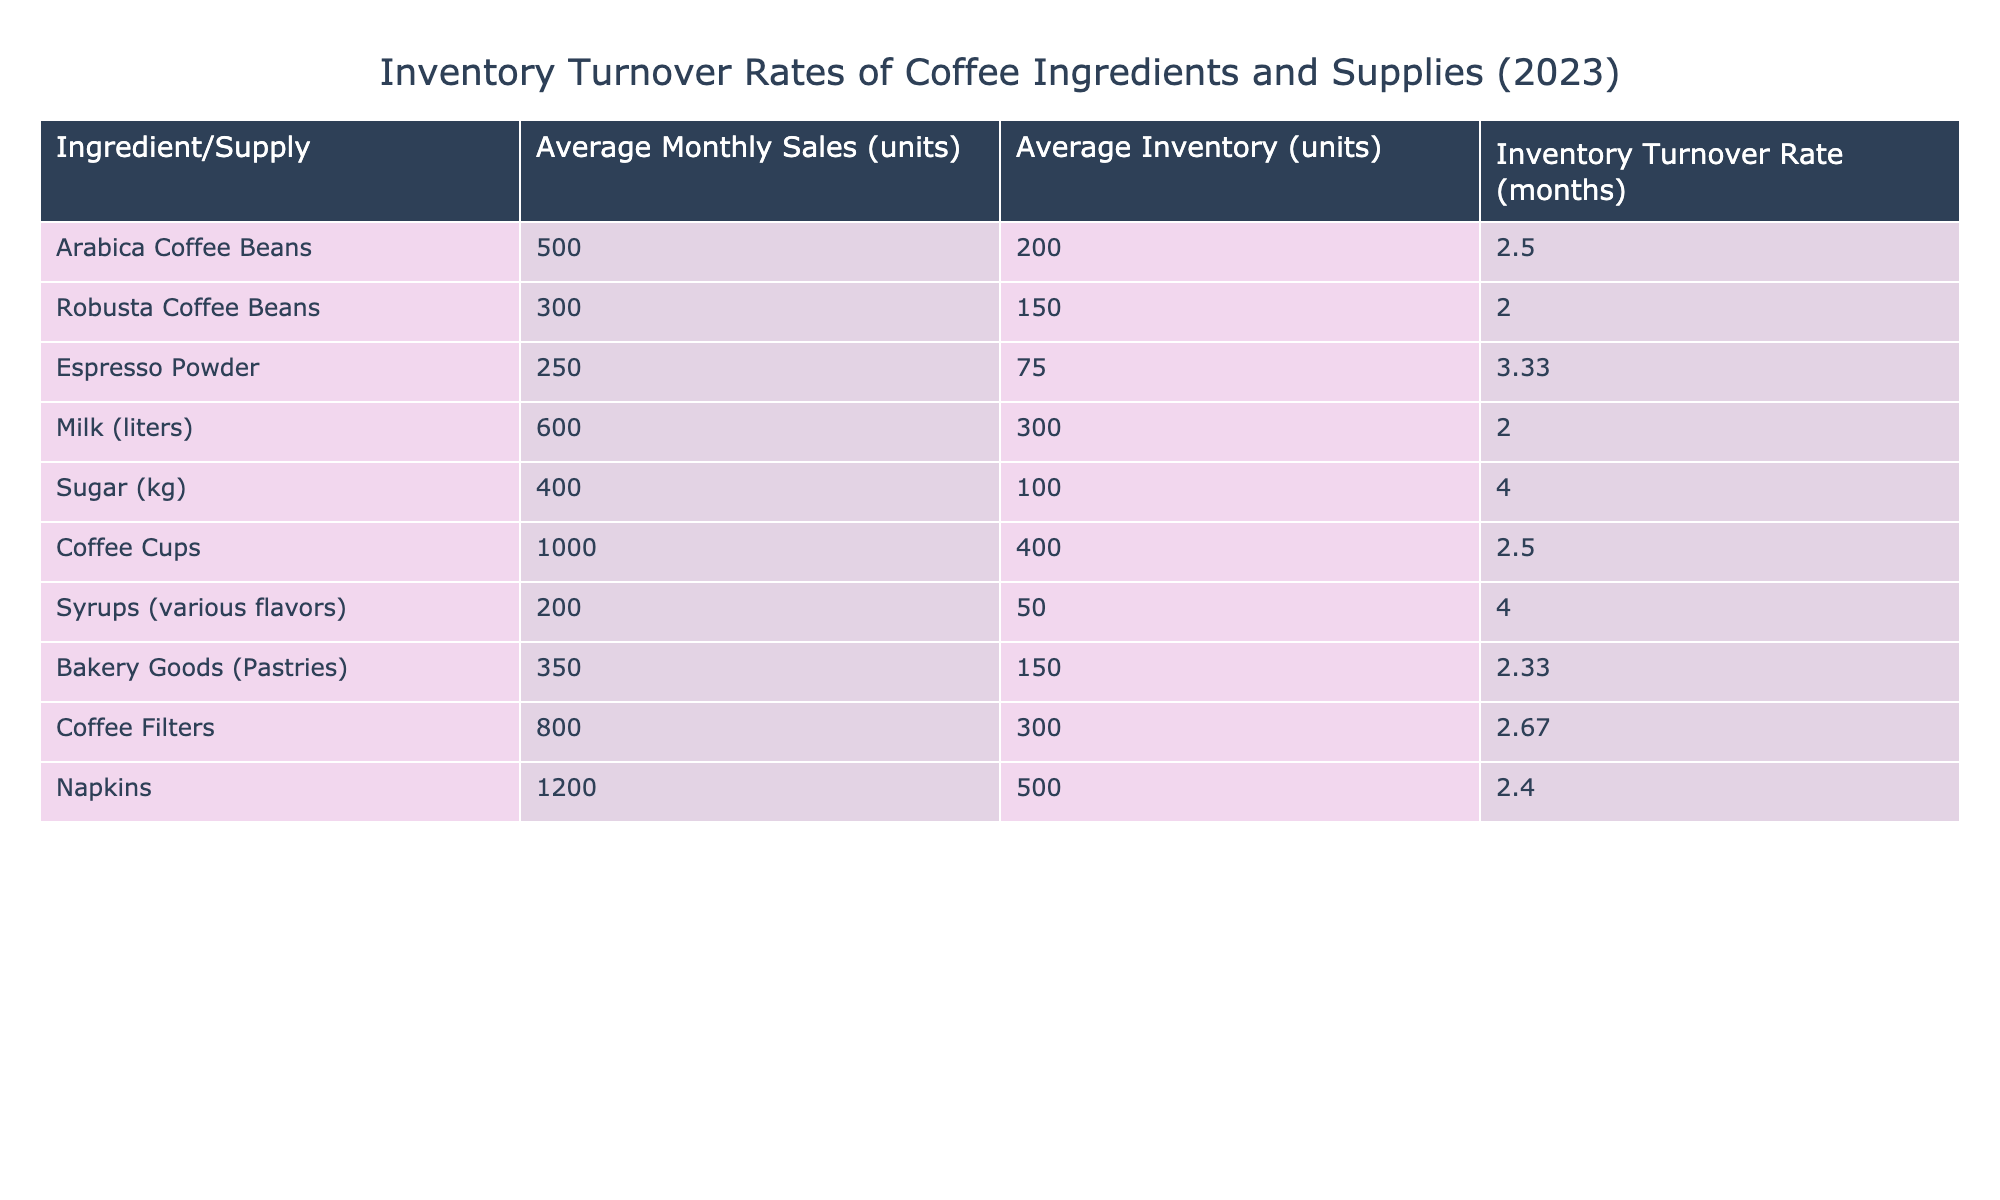What is the inventory turnover rate for Espresso Powder? From the table, for Espresso Powder, the inventory turnover rate is listed directly under the corresponding row, which shows a rate of 3.33 months.
Answer: 3.33 Which ingredient has the highest inventory turnover rate? The table lists the inventory turnover rates for all ingredients. By comparing the rates, Sugar has the highest inventory turnover rate at 4 months.
Answer: Sugar What is the total average inventory in units for all supplies? To find the total average inventory, add up all the average inventory values: 200 + 150 + 75 + 300 + 100 + 400 + 50 + 150 + 300 + 500 = 1825 units.
Answer: 1825 Is the inventory turnover rate for Robusta Coffee Beans higher than that for Milk? Comparing the two rates, Robusta Coffee Beans has an inventory turnover rate of 2 months, while Milk has a rate of 2 months. Therefore, Robusta is not higher than Milk.
Answer: No What is the average inventory turnover rate for all products? To calculate the average inventory turnover rate, you sum up all the rates: 2.5 + 2 + 3.33 + 2 + 4 + 2.5 + 4 + 2.33 + 2.67 + 2.4 = 26.63, then divide by the number of items (10), resulting in an average of 2.663.
Answer: 2.663 Which ingredient has the lowest average inventory? The comparison of average inventory across the ingredients shows that Syrups (various flavors) has the lowest average inventory at 50 units.
Answer: Syrups (various flavors) How much more milk is sold on average per month than Espresso Powder? The average monthly sales for Milk is 600 units and for Espresso Powder, it is 250 units. The difference is 600 - 250 = 350 units, meaning 350 more units of Milk are sold.
Answer: 350 Is the average inventory for Coffee Cups above or below 350 units? The average inventory for Coffee Cups is listed as 400 units, which is indeed above 350 units.
Answer: Above 